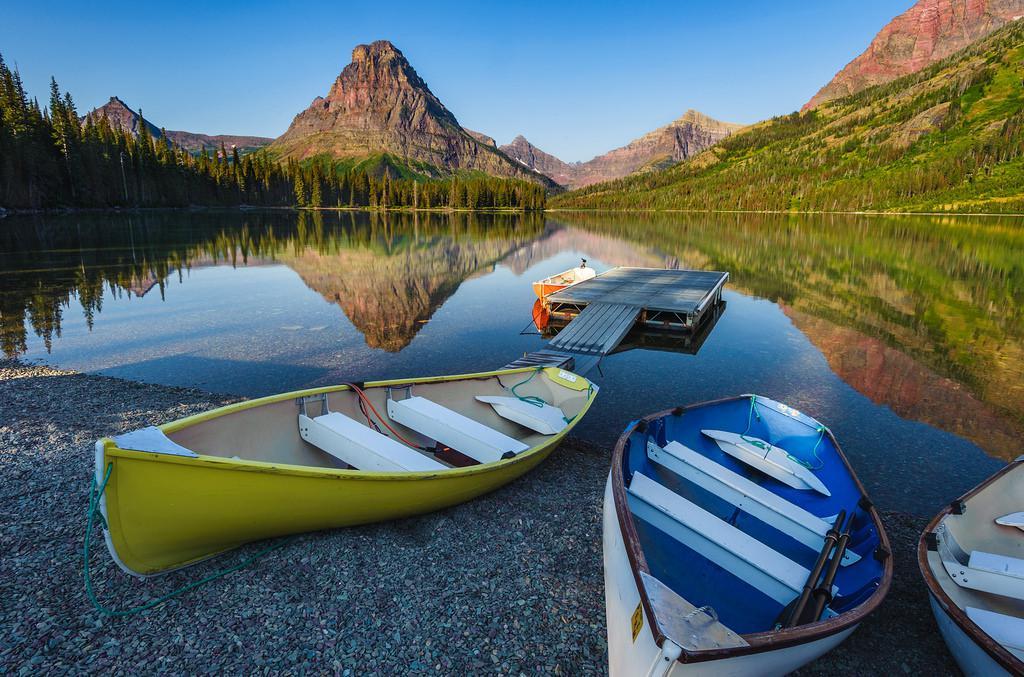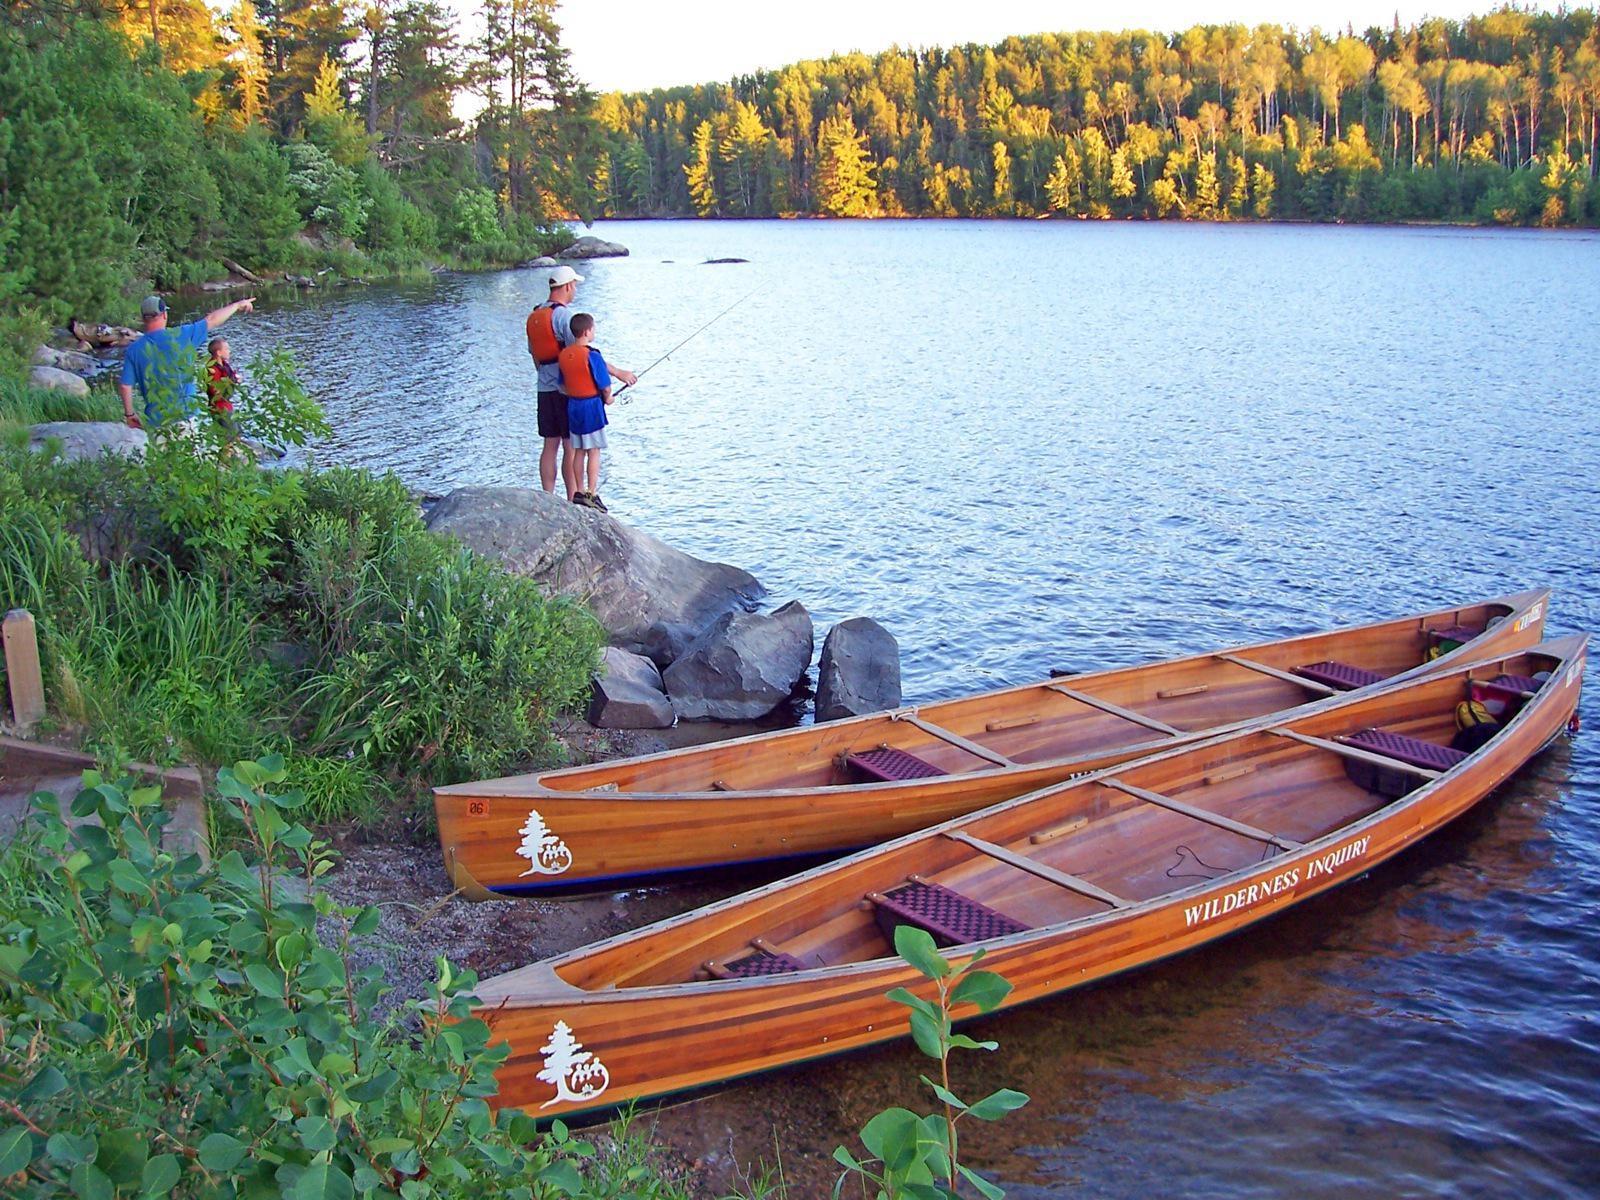The first image is the image on the left, the second image is the image on the right. For the images displayed, is the sentence "An image includes a canoe with multiple riders afloat on the water." factually correct? Answer yes or no. No. The first image is the image on the left, the second image is the image on the right. Considering the images on both sides, is "At least one person is standing on the shore in the image on the right." valid? Answer yes or no. Yes. 